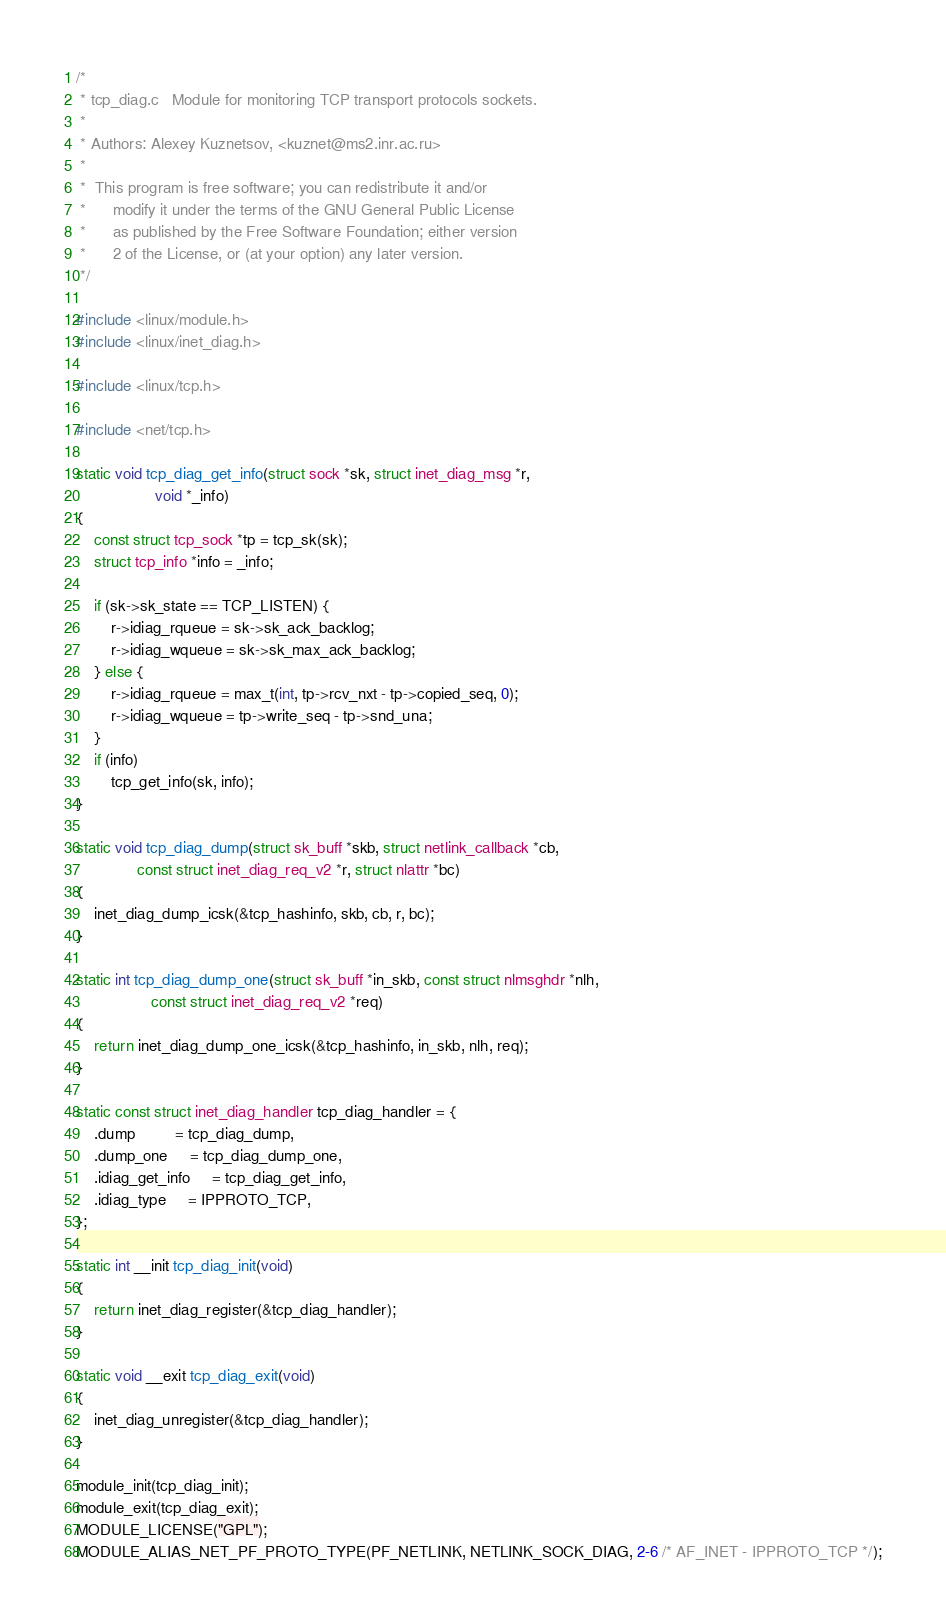Convert code to text. <code><loc_0><loc_0><loc_500><loc_500><_C_>/*
 * tcp_diag.c	Module for monitoring TCP transport protocols sockets.
 *
 * Authors:	Alexey Kuznetsov, <kuznet@ms2.inr.ac.ru>
 *
 *	This program is free software; you can redistribute it and/or
 *      modify it under the terms of the GNU General Public License
 *      as published by the Free Software Foundation; either version
 *      2 of the License, or (at your option) any later version.
 */

#include <linux/module.h>
#include <linux/inet_diag.h>

#include <linux/tcp.h>

#include <net/tcp.h>

static void tcp_diag_get_info(struct sock *sk, struct inet_diag_msg *r,
			      void *_info)
{
	const struct tcp_sock *tp = tcp_sk(sk);
	struct tcp_info *info = _info;

	if (sk->sk_state == TCP_LISTEN) {
		r->idiag_rqueue = sk->sk_ack_backlog;
		r->idiag_wqueue = sk->sk_max_ack_backlog;
	} else {
		r->idiag_rqueue = max_t(int, tp->rcv_nxt - tp->copied_seq, 0);
		r->idiag_wqueue = tp->write_seq - tp->snd_una;
	}
	if (info)
		tcp_get_info(sk, info);
}

static void tcp_diag_dump(struct sk_buff *skb, struct netlink_callback *cb,
			  const struct inet_diag_req_v2 *r, struct nlattr *bc)
{
	inet_diag_dump_icsk(&tcp_hashinfo, skb, cb, r, bc);
}

static int tcp_diag_dump_one(struct sk_buff *in_skb, const struct nlmsghdr *nlh,
			     const struct inet_diag_req_v2 *req)
{
	return inet_diag_dump_one_icsk(&tcp_hashinfo, in_skb, nlh, req);
}

static const struct inet_diag_handler tcp_diag_handler = {
	.dump		 = tcp_diag_dump,
	.dump_one	 = tcp_diag_dump_one,
	.idiag_get_info	 = tcp_diag_get_info,
	.idiag_type	 = IPPROTO_TCP,
};

static int __init tcp_diag_init(void)
{
	return inet_diag_register(&tcp_diag_handler);
}

static void __exit tcp_diag_exit(void)
{
	inet_diag_unregister(&tcp_diag_handler);
}

module_init(tcp_diag_init);
module_exit(tcp_diag_exit);
MODULE_LICENSE("GPL");
MODULE_ALIAS_NET_PF_PROTO_TYPE(PF_NETLINK, NETLINK_SOCK_DIAG, 2-6 /* AF_INET - IPPROTO_TCP */);
</code> 